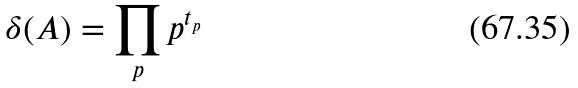Convert formula to latex. <formula><loc_0><loc_0><loc_500><loc_500>\delta ( A ) = \prod _ { p } p ^ { t _ { p } }</formula> 